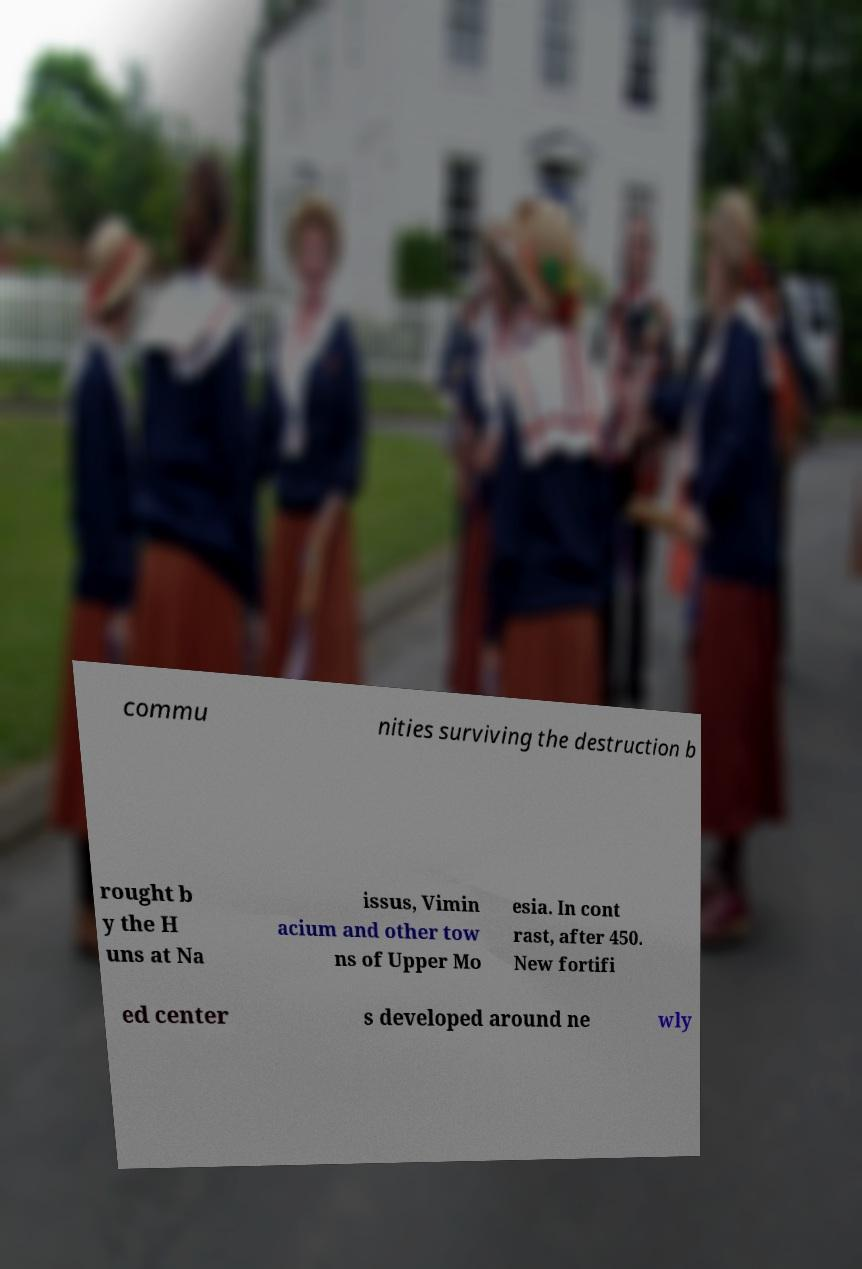What messages or text are displayed in this image? I need them in a readable, typed format. commu nities surviving the destruction b rought b y the H uns at Na issus, Vimin acium and other tow ns of Upper Mo esia. In cont rast, after 450. New fortifi ed center s developed around ne wly 